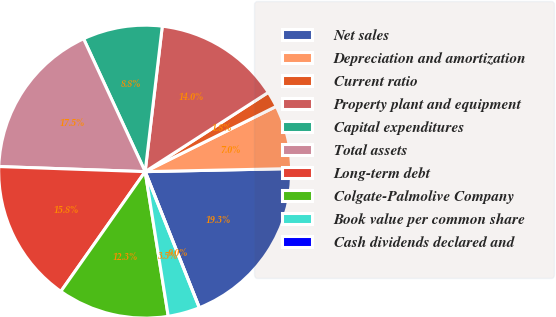Convert chart. <chart><loc_0><loc_0><loc_500><loc_500><pie_chart><fcel>Net sales<fcel>Depreciation and amortization<fcel>Current ratio<fcel>Property plant and equipment<fcel>Capital expenditures<fcel>Total assets<fcel>Long-term debt<fcel>Colgate-Palmolive Company<fcel>Book value per common share<fcel>Cash dividends declared and<nl><fcel>19.3%<fcel>7.02%<fcel>1.75%<fcel>14.03%<fcel>8.77%<fcel>17.54%<fcel>15.79%<fcel>12.28%<fcel>3.51%<fcel>0.0%<nl></chart> 